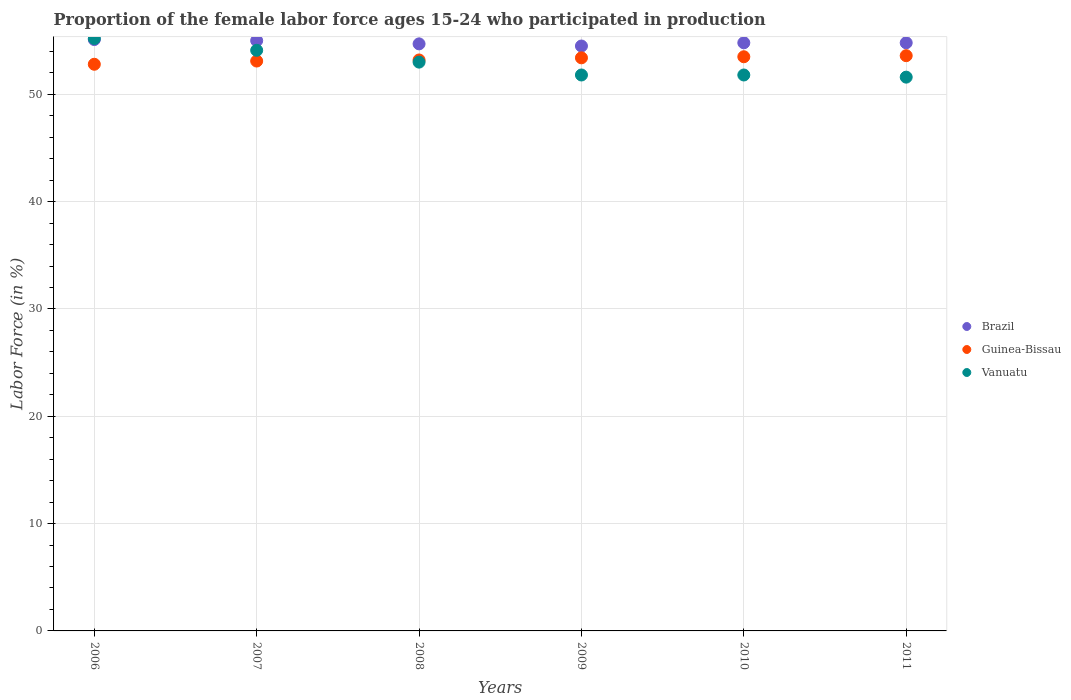How many different coloured dotlines are there?
Keep it short and to the point. 3. What is the proportion of the female labor force who participated in production in Guinea-Bissau in 2006?
Your answer should be compact. 52.8. Across all years, what is the maximum proportion of the female labor force who participated in production in Guinea-Bissau?
Give a very brief answer. 53.6. Across all years, what is the minimum proportion of the female labor force who participated in production in Brazil?
Offer a terse response. 54.5. In which year was the proportion of the female labor force who participated in production in Brazil maximum?
Offer a very short reply. 2006. What is the total proportion of the female labor force who participated in production in Vanuatu in the graph?
Make the answer very short. 317.5. What is the difference between the proportion of the female labor force who participated in production in Vanuatu in 2008 and that in 2009?
Make the answer very short. 1.2. What is the difference between the proportion of the female labor force who participated in production in Guinea-Bissau in 2006 and the proportion of the female labor force who participated in production in Brazil in 2010?
Your answer should be compact. -2. What is the average proportion of the female labor force who participated in production in Vanuatu per year?
Ensure brevity in your answer.  52.92. In the year 2008, what is the difference between the proportion of the female labor force who participated in production in Guinea-Bissau and proportion of the female labor force who participated in production in Brazil?
Provide a succinct answer. -1.5. What is the ratio of the proportion of the female labor force who participated in production in Brazil in 2008 to that in 2011?
Your answer should be compact. 1. Is the difference between the proportion of the female labor force who participated in production in Guinea-Bissau in 2006 and 2007 greater than the difference between the proportion of the female labor force who participated in production in Brazil in 2006 and 2007?
Your answer should be very brief. No. What is the difference between the highest and the second highest proportion of the female labor force who participated in production in Brazil?
Your response must be concise. 0.1. What is the difference between the highest and the lowest proportion of the female labor force who participated in production in Vanuatu?
Your answer should be very brief. 3.6. Is the sum of the proportion of the female labor force who participated in production in Vanuatu in 2006 and 2009 greater than the maximum proportion of the female labor force who participated in production in Guinea-Bissau across all years?
Ensure brevity in your answer.  Yes. Is the proportion of the female labor force who participated in production in Guinea-Bissau strictly greater than the proportion of the female labor force who participated in production in Vanuatu over the years?
Keep it short and to the point. No. Is the proportion of the female labor force who participated in production in Guinea-Bissau strictly less than the proportion of the female labor force who participated in production in Vanuatu over the years?
Offer a terse response. No. How many dotlines are there?
Offer a very short reply. 3. How many years are there in the graph?
Offer a terse response. 6. What is the difference between two consecutive major ticks on the Y-axis?
Your response must be concise. 10. Does the graph contain grids?
Your answer should be very brief. Yes. How are the legend labels stacked?
Make the answer very short. Vertical. What is the title of the graph?
Offer a very short reply. Proportion of the female labor force ages 15-24 who participated in production. Does "Monaco" appear as one of the legend labels in the graph?
Your answer should be very brief. No. What is the label or title of the Y-axis?
Give a very brief answer. Labor Force (in %). What is the Labor Force (in %) of Brazil in 2006?
Ensure brevity in your answer.  55.1. What is the Labor Force (in %) of Guinea-Bissau in 2006?
Make the answer very short. 52.8. What is the Labor Force (in %) in Vanuatu in 2006?
Your response must be concise. 55.2. What is the Labor Force (in %) of Guinea-Bissau in 2007?
Give a very brief answer. 53.1. What is the Labor Force (in %) in Vanuatu in 2007?
Make the answer very short. 54.1. What is the Labor Force (in %) in Brazil in 2008?
Provide a succinct answer. 54.7. What is the Labor Force (in %) of Guinea-Bissau in 2008?
Your answer should be compact. 53.2. What is the Labor Force (in %) in Vanuatu in 2008?
Your response must be concise. 53. What is the Labor Force (in %) in Brazil in 2009?
Your answer should be very brief. 54.5. What is the Labor Force (in %) of Guinea-Bissau in 2009?
Your response must be concise. 53.4. What is the Labor Force (in %) in Vanuatu in 2009?
Offer a terse response. 51.8. What is the Labor Force (in %) in Brazil in 2010?
Your answer should be very brief. 54.8. What is the Labor Force (in %) in Guinea-Bissau in 2010?
Give a very brief answer. 53.5. What is the Labor Force (in %) of Vanuatu in 2010?
Your answer should be very brief. 51.8. What is the Labor Force (in %) of Brazil in 2011?
Your response must be concise. 54.8. What is the Labor Force (in %) of Guinea-Bissau in 2011?
Offer a terse response. 53.6. What is the Labor Force (in %) in Vanuatu in 2011?
Your answer should be compact. 51.6. Across all years, what is the maximum Labor Force (in %) of Brazil?
Give a very brief answer. 55.1. Across all years, what is the maximum Labor Force (in %) in Guinea-Bissau?
Offer a terse response. 53.6. Across all years, what is the maximum Labor Force (in %) in Vanuatu?
Your answer should be compact. 55.2. Across all years, what is the minimum Labor Force (in %) in Brazil?
Your answer should be compact. 54.5. Across all years, what is the minimum Labor Force (in %) of Guinea-Bissau?
Keep it short and to the point. 52.8. Across all years, what is the minimum Labor Force (in %) in Vanuatu?
Your answer should be very brief. 51.6. What is the total Labor Force (in %) in Brazil in the graph?
Your response must be concise. 328.9. What is the total Labor Force (in %) of Guinea-Bissau in the graph?
Ensure brevity in your answer.  319.6. What is the total Labor Force (in %) in Vanuatu in the graph?
Offer a very short reply. 317.5. What is the difference between the Labor Force (in %) in Brazil in 2006 and that in 2007?
Your answer should be compact. 0.1. What is the difference between the Labor Force (in %) in Brazil in 2006 and that in 2008?
Keep it short and to the point. 0.4. What is the difference between the Labor Force (in %) of Guinea-Bissau in 2006 and that in 2009?
Give a very brief answer. -0.6. What is the difference between the Labor Force (in %) of Brazil in 2006 and that in 2010?
Your response must be concise. 0.3. What is the difference between the Labor Force (in %) of Guinea-Bissau in 2006 and that in 2010?
Give a very brief answer. -0.7. What is the difference between the Labor Force (in %) of Vanuatu in 2006 and that in 2010?
Ensure brevity in your answer.  3.4. What is the difference between the Labor Force (in %) of Brazil in 2006 and that in 2011?
Offer a terse response. 0.3. What is the difference between the Labor Force (in %) of Vanuatu in 2006 and that in 2011?
Your answer should be very brief. 3.6. What is the difference between the Labor Force (in %) of Brazil in 2007 and that in 2008?
Offer a terse response. 0.3. What is the difference between the Labor Force (in %) of Guinea-Bissau in 2007 and that in 2008?
Offer a terse response. -0.1. What is the difference between the Labor Force (in %) of Vanuatu in 2007 and that in 2008?
Your answer should be compact. 1.1. What is the difference between the Labor Force (in %) in Brazil in 2007 and that in 2009?
Offer a terse response. 0.5. What is the difference between the Labor Force (in %) of Guinea-Bissau in 2007 and that in 2009?
Keep it short and to the point. -0.3. What is the difference between the Labor Force (in %) of Brazil in 2007 and that in 2011?
Give a very brief answer. 0.2. What is the difference between the Labor Force (in %) of Guinea-Bissau in 2007 and that in 2011?
Offer a terse response. -0.5. What is the difference between the Labor Force (in %) of Brazil in 2008 and that in 2010?
Your response must be concise. -0.1. What is the difference between the Labor Force (in %) of Guinea-Bissau in 2009 and that in 2010?
Give a very brief answer. -0.1. What is the difference between the Labor Force (in %) of Brazil in 2009 and that in 2011?
Give a very brief answer. -0.3. What is the difference between the Labor Force (in %) of Guinea-Bissau in 2009 and that in 2011?
Ensure brevity in your answer.  -0.2. What is the difference between the Labor Force (in %) in Brazil in 2010 and that in 2011?
Keep it short and to the point. 0. What is the difference between the Labor Force (in %) of Vanuatu in 2010 and that in 2011?
Your response must be concise. 0.2. What is the difference between the Labor Force (in %) in Brazil in 2006 and the Labor Force (in %) in Guinea-Bissau in 2007?
Your response must be concise. 2. What is the difference between the Labor Force (in %) in Brazil in 2006 and the Labor Force (in %) in Vanuatu in 2007?
Make the answer very short. 1. What is the difference between the Labor Force (in %) in Guinea-Bissau in 2006 and the Labor Force (in %) in Vanuatu in 2007?
Offer a terse response. -1.3. What is the difference between the Labor Force (in %) of Brazil in 2006 and the Labor Force (in %) of Guinea-Bissau in 2008?
Provide a short and direct response. 1.9. What is the difference between the Labor Force (in %) in Guinea-Bissau in 2006 and the Labor Force (in %) in Vanuatu in 2010?
Make the answer very short. 1. What is the difference between the Labor Force (in %) of Guinea-Bissau in 2006 and the Labor Force (in %) of Vanuatu in 2011?
Ensure brevity in your answer.  1.2. What is the difference between the Labor Force (in %) of Guinea-Bissau in 2007 and the Labor Force (in %) of Vanuatu in 2008?
Your answer should be very brief. 0.1. What is the difference between the Labor Force (in %) of Brazil in 2007 and the Labor Force (in %) of Vanuatu in 2009?
Your answer should be very brief. 3.2. What is the difference between the Labor Force (in %) of Guinea-Bissau in 2007 and the Labor Force (in %) of Vanuatu in 2009?
Offer a very short reply. 1.3. What is the difference between the Labor Force (in %) of Brazil in 2007 and the Labor Force (in %) of Vanuatu in 2010?
Give a very brief answer. 3.2. What is the difference between the Labor Force (in %) of Brazil in 2007 and the Labor Force (in %) of Guinea-Bissau in 2011?
Your answer should be very brief. 1.4. What is the difference between the Labor Force (in %) of Brazil in 2008 and the Labor Force (in %) of Vanuatu in 2009?
Offer a terse response. 2.9. What is the difference between the Labor Force (in %) in Brazil in 2008 and the Labor Force (in %) in Guinea-Bissau in 2010?
Keep it short and to the point. 1.2. What is the difference between the Labor Force (in %) of Brazil in 2008 and the Labor Force (in %) of Vanuatu in 2010?
Your answer should be compact. 2.9. What is the difference between the Labor Force (in %) of Brazil in 2008 and the Labor Force (in %) of Guinea-Bissau in 2011?
Offer a very short reply. 1.1. What is the difference between the Labor Force (in %) in Brazil in 2008 and the Labor Force (in %) in Vanuatu in 2011?
Your answer should be very brief. 3.1. What is the difference between the Labor Force (in %) in Guinea-Bissau in 2008 and the Labor Force (in %) in Vanuatu in 2011?
Your answer should be compact. 1.6. What is the difference between the Labor Force (in %) of Guinea-Bissau in 2009 and the Labor Force (in %) of Vanuatu in 2010?
Give a very brief answer. 1.6. What is the difference between the Labor Force (in %) in Brazil in 2009 and the Labor Force (in %) in Guinea-Bissau in 2011?
Your response must be concise. 0.9. What is the difference between the Labor Force (in %) of Brazil in 2010 and the Labor Force (in %) of Guinea-Bissau in 2011?
Give a very brief answer. 1.2. What is the difference between the Labor Force (in %) in Brazil in 2010 and the Labor Force (in %) in Vanuatu in 2011?
Your answer should be compact. 3.2. What is the average Labor Force (in %) in Brazil per year?
Make the answer very short. 54.82. What is the average Labor Force (in %) of Guinea-Bissau per year?
Give a very brief answer. 53.27. What is the average Labor Force (in %) of Vanuatu per year?
Keep it short and to the point. 52.92. In the year 2006, what is the difference between the Labor Force (in %) in Brazil and Labor Force (in %) in Guinea-Bissau?
Your response must be concise. 2.3. In the year 2006, what is the difference between the Labor Force (in %) of Brazil and Labor Force (in %) of Vanuatu?
Your response must be concise. -0.1. In the year 2007, what is the difference between the Labor Force (in %) of Brazil and Labor Force (in %) of Guinea-Bissau?
Ensure brevity in your answer.  1.9. In the year 2007, what is the difference between the Labor Force (in %) in Brazil and Labor Force (in %) in Vanuatu?
Keep it short and to the point. 0.9. In the year 2007, what is the difference between the Labor Force (in %) in Guinea-Bissau and Labor Force (in %) in Vanuatu?
Provide a short and direct response. -1. In the year 2009, what is the difference between the Labor Force (in %) of Brazil and Labor Force (in %) of Vanuatu?
Offer a terse response. 2.7. In the year 2009, what is the difference between the Labor Force (in %) in Guinea-Bissau and Labor Force (in %) in Vanuatu?
Offer a very short reply. 1.6. In the year 2010, what is the difference between the Labor Force (in %) in Brazil and Labor Force (in %) in Guinea-Bissau?
Keep it short and to the point. 1.3. In the year 2010, what is the difference between the Labor Force (in %) of Brazil and Labor Force (in %) of Vanuatu?
Your response must be concise. 3. In the year 2010, what is the difference between the Labor Force (in %) of Guinea-Bissau and Labor Force (in %) of Vanuatu?
Keep it short and to the point. 1.7. What is the ratio of the Labor Force (in %) of Brazil in 2006 to that in 2007?
Offer a very short reply. 1. What is the ratio of the Labor Force (in %) in Vanuatu in 2006 to that in 2007?
Your answer should be compact. 1.02. What is the ratio of the Labor Force (in %) in Brazil in 2006 to that in 2008?
Keep it short and to the point. 1.01. What is the ratio of the Labor Force (in %) in Guinea-Bissau in 2006 to that in 2008?
Make the answer very short. 0.99. What is the ratio of the Labor Force (in %) of Vanuatu in 2006 to that in 2008?
Give a very brief answer. 1.04. What is the ratio of the Labor Force (in %) of Guinea-Bissau in 2006 to that in 2009?
Your answer should be compact. 0.99. What is the ratio of the Labor Force (in %) of Vanuatu in 2006 to that in 2009?
Keep it short and to the point. 1.07. What is the ratio of the Labor Force (in %) of Brazil in 2006 to that in 2010?
Give a very brief answer. 1.01. What is the ratio of the Labor Force (in %) of Guinea-Bissau in 2006 to that in 2010?
Your response must be concise. 0.99. What is the ratio of the Labor Force (in %) in Vanuatu in 2006 to that in 2010?
Give a very brief answer. 1.07. What is the ratio of the Labor Force (in %) of Brazil in 2006 to that in 2011?
Offer a very short reply. 1.01. What is the ratio of the Labor Force (in %) in Guinea-Bissau in 2006 to that in 2011?
Give a very brief answer. 0.99. What is the ratio of the Labor Force (in %) in Vanuatu in 2006 to that in 2011?
Your response must be concise. 1.07. What is the ratio of the Labor Force (in %) of Brazil in 2007 to that in 2008?
Your response must be concise. 1.01. What is the ratio of the Labor Force (in %) in Vanuatu in 2007 to that in 2008?
Offer a terse response. 1.02. What is the ratio of the Labor Force (in %) of Brazil in 2007 to that in 2009?
Provide a short and direct response. 1.01. What is the ratio of the Labor Force (in %) of Guinea-Bissau in 2007 to that in 2009?
Make the answer very short. 0.99. What is the ratio of the Labor Force (in %) in Vanuatu in 2007 to that in 2009?
Your answer should be compact. 1.04. What is the ratio of the Labor Force (in %) of Brazil in 2007 to that in 2010?
Provide a succinct answer. 1. What is the ratio of the Labor Force (in %) in Vanuatu in 2007 to that in 2010?
Provide a short and direct response. 1.04. What is the ratio of the Labor Force (in %) of Vanuatu in 2007 to that in 2011?
Keep it short and to the point. 1.05. What is the ratio of the Labor Force (in %) in Vanuatu in 2008 to that in 2009?
Your answer should be compact. 1.02. What is the ratio of the Labor Force (in %) in Vanuatu in 2008 to that in 2010?
Your response must be concise. 1.02. What is the ratio of the Labor Force (in %) in Brazil in 2008 to that in 2011?
Offer a terse response. 1. What is the ratio of the Labor Force (in %) in Vanuatu in 2008 to that in 2011?
Your answer should be very brief. 1.03. What is the ratio of the Labor Force (in %) in Guinea-Bissau in 2009 to that in 2010?
Offer a terse response. 1. What is the ratio of the Labor Force (in %) of Vanuatu in 2009 to that in 2010?
Offer a very short reply. 1. What is the ratio of the Labor Force (in %) in Vanuatu in 2010 to that in 2011?
Offer a terse response. 1. What is the difference between the highest and the second highest Labor Force (in %) in Brazil?
Your answer should be very brief. 0.1. What is the difference between the highest and the second highest Labor Force (in %) in Guinea-Bissau?
Keep it short and to the point. 0.1. What is the difference between the highest and the second highest Labor Force (in %) in Vanuatu?
Provide a short and direct response. 1.1. 